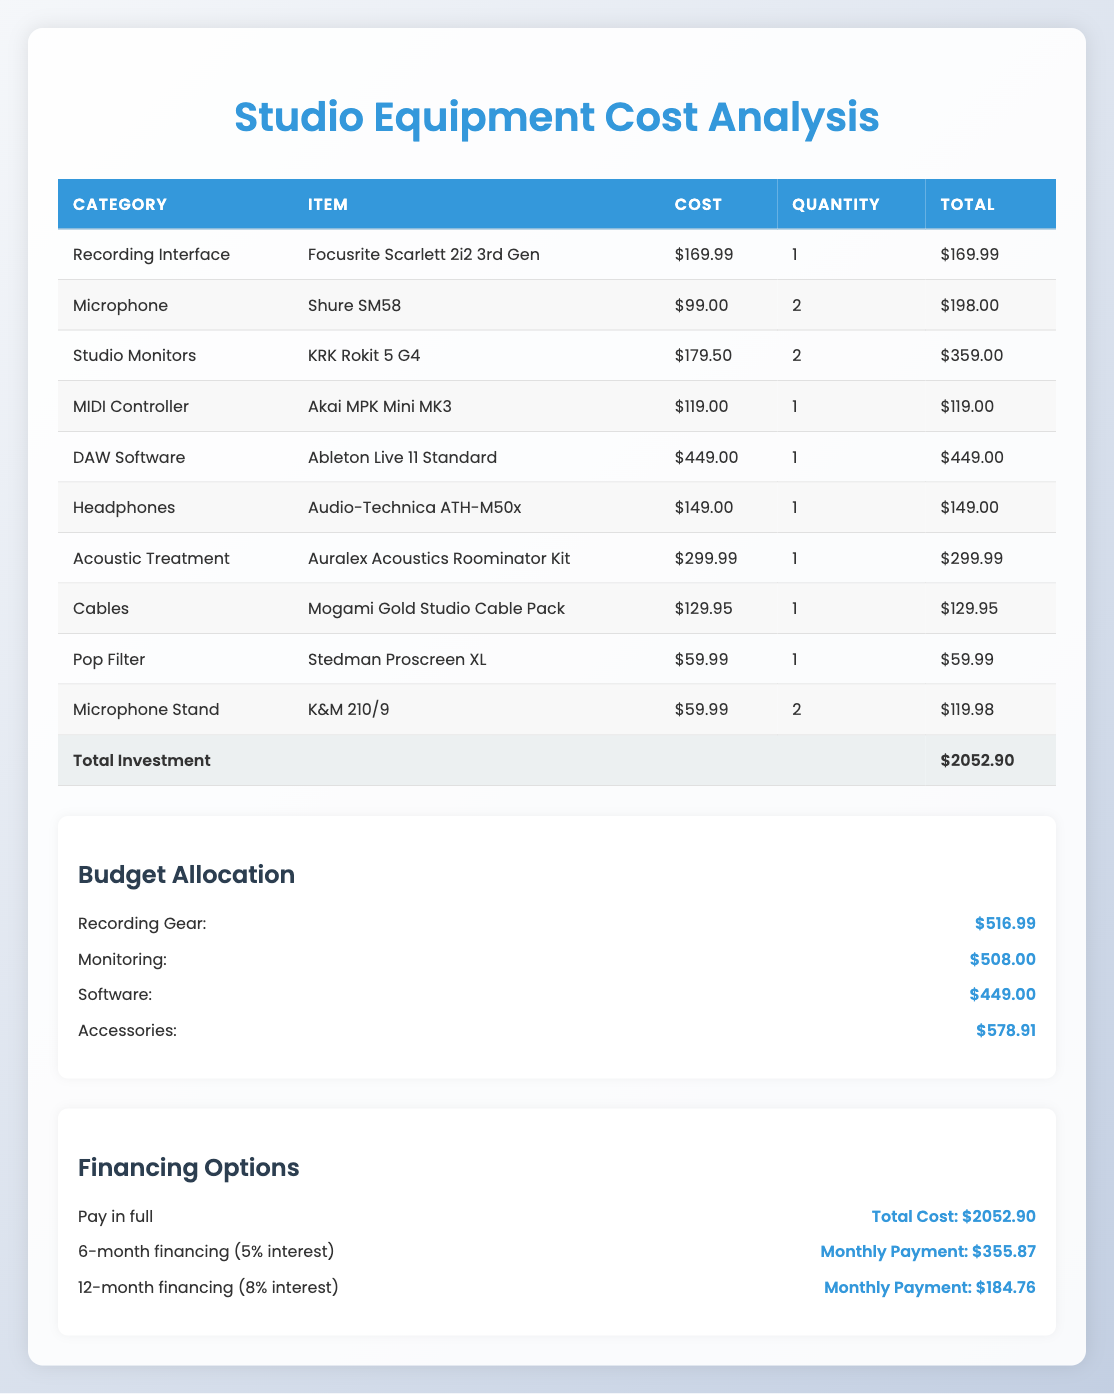What is the total investment for the studio equipment? The total investment is explicitly listed in the table as $2052.90.
Answer: $2052.90 How much did you spend on microphones in total? There are two microphones mentioned, the Shure SM58. The cost of one is $99.00, and there are two, so the total cost is 99.00 * 2 = 198.00.
Answer: $198.00 Is the cost of the MIDI Controller less than $150? The cost of the Akai MPK Mini MK3 MIDI Controller is $119.00, which is indeed less than $150.
Answer: Yes What category has the highest total cost? By looking at the total costs per category, the DAW Software has the highest total cost of $449.00, compared to other categories.
Answer: DAW Software What is the combined cost of accessories (including cables and pop filter)? The cables cost $129.95, and the pop filter costs $59.99, so the total cost of accessories is 129.95 + 59.99 = 189.94.
Answer: $189.94 How much budget was allocated for monitoring equipment? The budget allocation for monitoring is explicitly stated in the table as $508.00.
Answer: $508.00 How much more budget is allocated for accessories compared to recording gear? From the budget allocation, accessories total $578.91, while recording gear is $516.99. The difference is 578.91 - 516.99 = $61.92.
Answer: $61.92 What is the average cost of studio monitors and microphones based on their total costs? The total cost of two studio monitors is $359.00 and the total cost of two microphones is $198.00. The average is calculated as (359.00 + 198.00) / 2 = 278.50.
Answer: $278.50 If you choose the 12-month financing plan, how much extra will you pay compared to paying in full? The total cost with the 12-month financing plan is $2217.12. When you pay in full, it's $2052.90, making the extra cost 2217.12 - 2052.90 = $164.22 more.
Answer: $164.22 